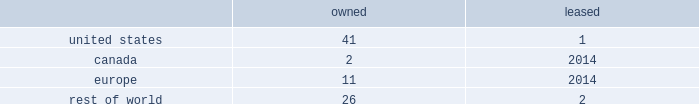While we have remediated the previously-identified material weakness in our internal control over financial reporting , we may identify other material weaknesses in the future .
In november 2017 , we restated our consolidated financial statements for the quarters ended april 1 , 2017 and july 1 , 2017 in order to correctly classify cash receipts from the payments on sold receivables ( which are cash receipts on the underlying trade receivables that have already been securitized ) to cash provided by investing activities ( from cash provided by operating activities ) within our condensed consolidated statements of cash flows .
In connection with these restatements , management identified a material weakness in our internal control over financial reporting related to the misapplication of accounting standards update 2016-15 .
Specifically , we did not maintain effective controls over the adoption of new accounting standards , including communication with the appropriate individuals in coming to our conclusions on the application of new accounting standards .
As a result of this material weakness , our management concluded that we did not maintain effective internal control over financial reporting as of april 1 , 2017 and july 1 , 2017 .
While we have remediated the material weakness and our management has determined that our disclosure controls and procedures were effective as of december 30 , 2017 , there can be no assurance that our controls will remain adequate .
The effectiveness of our internal control over financial reporting is subject to various inherent limitations , including judgments used in decision-making , the nature and complexity of the transactions we undertake , assumptions about the likelihood of future events , the soundness of our systems , cost limitations , and other limitations .
If other material weaknesses or significant deficiencies in our internal control are discovered or occur in the future or we otherwise must restate our financial statements , it could materially and adversely affect our business and results of operations or financial condition , restrict our ability to access the capital markets , require us to expend significant resources to correct the weaknesses or deficiencies , subject us to fines , penalties , investigations or judgments , harm our reputation , or otherwise cause a decline in investor confidence .
Item 1b .
Unresolved staff comments .
Item 2 .
Properties .
Our corporate co-headquarters are located in pittsburgh , pennsylvania and chicago , illinois .
Our co-headquarters are leased and house certain executive offices , our u.s .
Business units , and our administrative , finance , legal , and human resource functions .
We maintain additional owned and leased offices throughout the regions in which we operate .
We manufacture our products in our network of manufacturing and processing facilities located throughout the world .
As of december 30 , 2017 , we operated 83 manufacturing and processing facilities .
We own 80 and lease three of these facilities .
Our manufacturing and processing facilities count by segment as of december 30 , 2017 was: .
We maintain all of our manufacturing and processing facilities in good condition and believe they are suitable and are adequate for our present needs .
We also enter into co-manufacturing arrangements with third parties if we determine it is advantageous to outsource the production of any of our products .
Item 3 .
Legal proceedings .
We are routinely involved in legal proceedings , claims , and governmental inquiries , inspections or investigations ( 201clegal matters 201d ) arising in the ordinary course of our business .
While we cannot predict with certainty the results of legal matters in which we are currently involved or may in the future be involved , we do not expect that the ultimate costs to resolve any of the legal matters that are currently pending will have a material adverse effect on our financial condition or results of operations .
Item 4 .
Mine safety disclosures .
Not applicable. .
What portion of the company owned facilities are located in united states? 
Computations: (41 / 80)
Answer: 0.5125. 